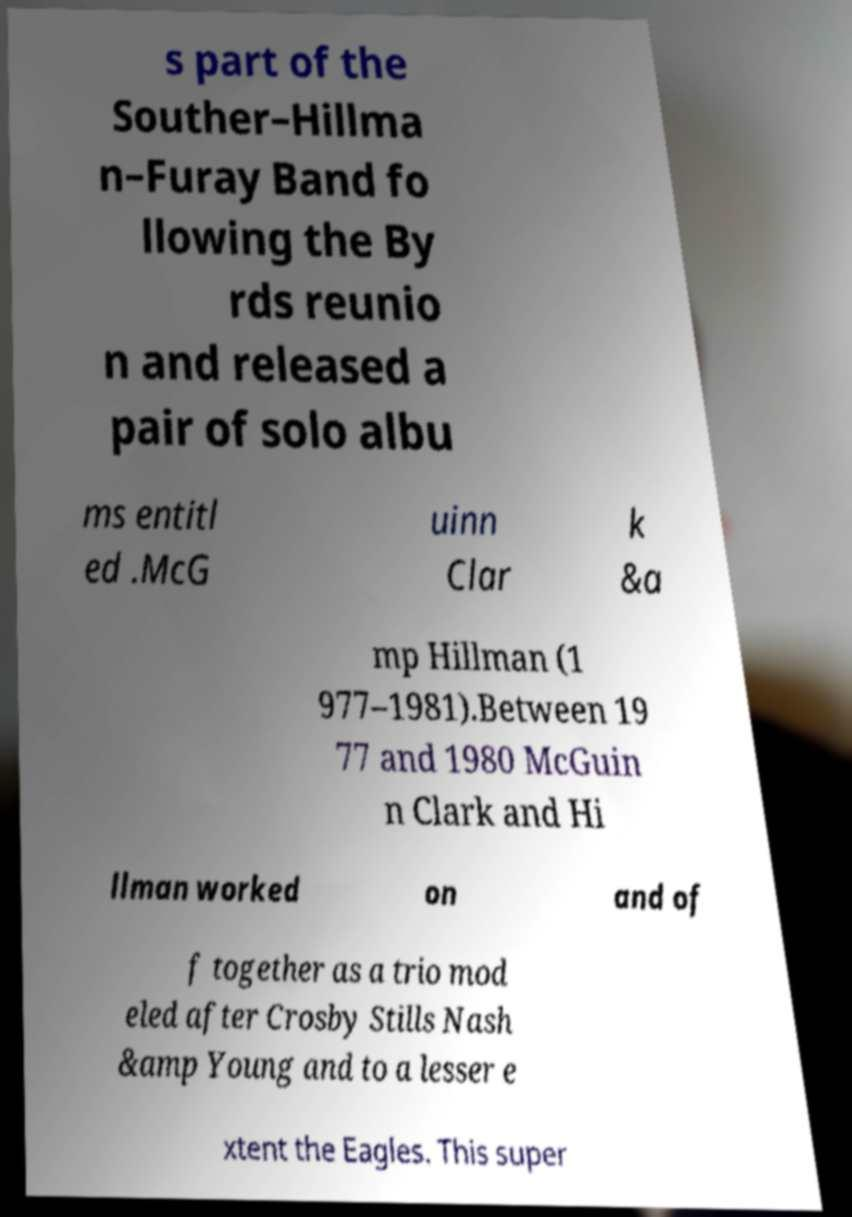Could you extract and type out the text from this image? s part of the Souther–Hillma n–Furay Band fo llowing the By rds reunio n and released a pair of solo albu ms entitl ed .McG uinn Clar k &a mp Hillman (1 977–1981).Between 19 77 and 1980 McGuin n Clark and Hi llman worked on and of f together as a trio mod eled after Crosby Stills Nash &amp Young and to a lesser e xtent the Eagles. This super 